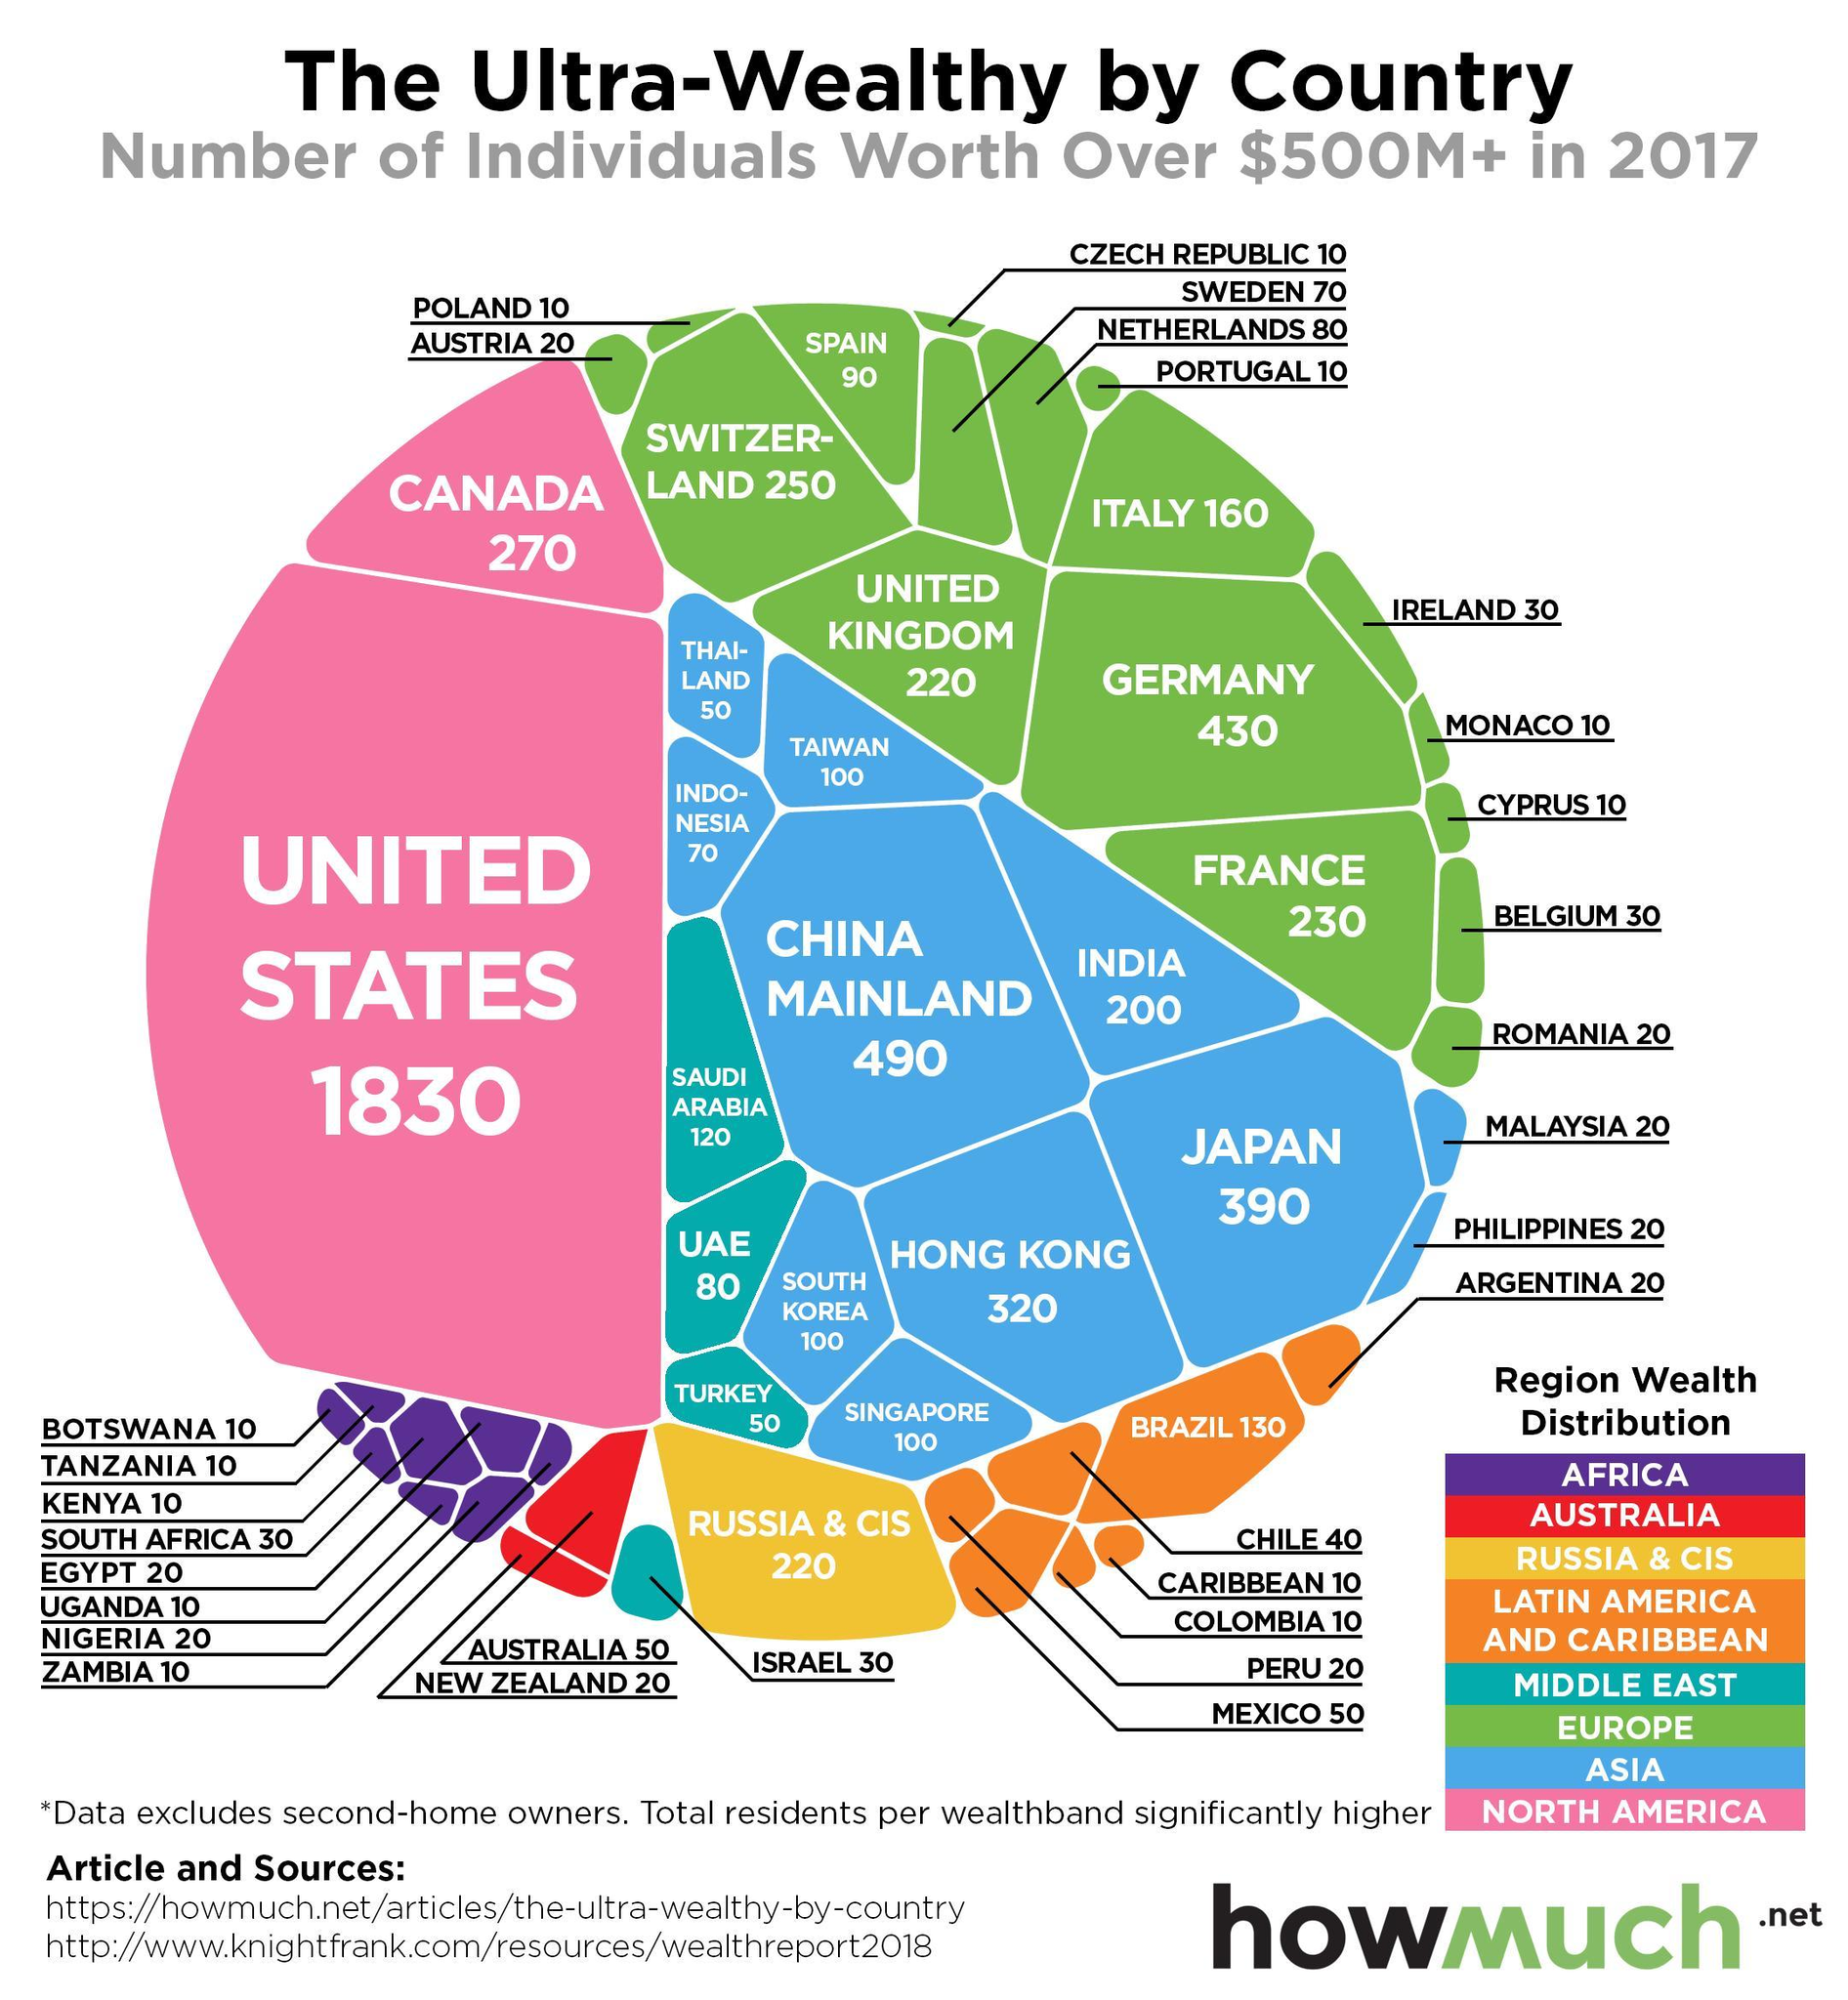Which country in the European region has the second-highest number of ultra-wealthy individuals in 2017?
Answer the question with a short phrase. SWITZERLAND What is the number of individuals worth over $500M+ in UAE in 2017? 80 Which country in the Asian region has the least number of ultra-wealthy individuals in 2017? THAILAND Which country has the highest number of ultra-wealthy individuals in 2017? UNITED STATES What is the number of individuals worth over $500M+ in India in 2017? 200 